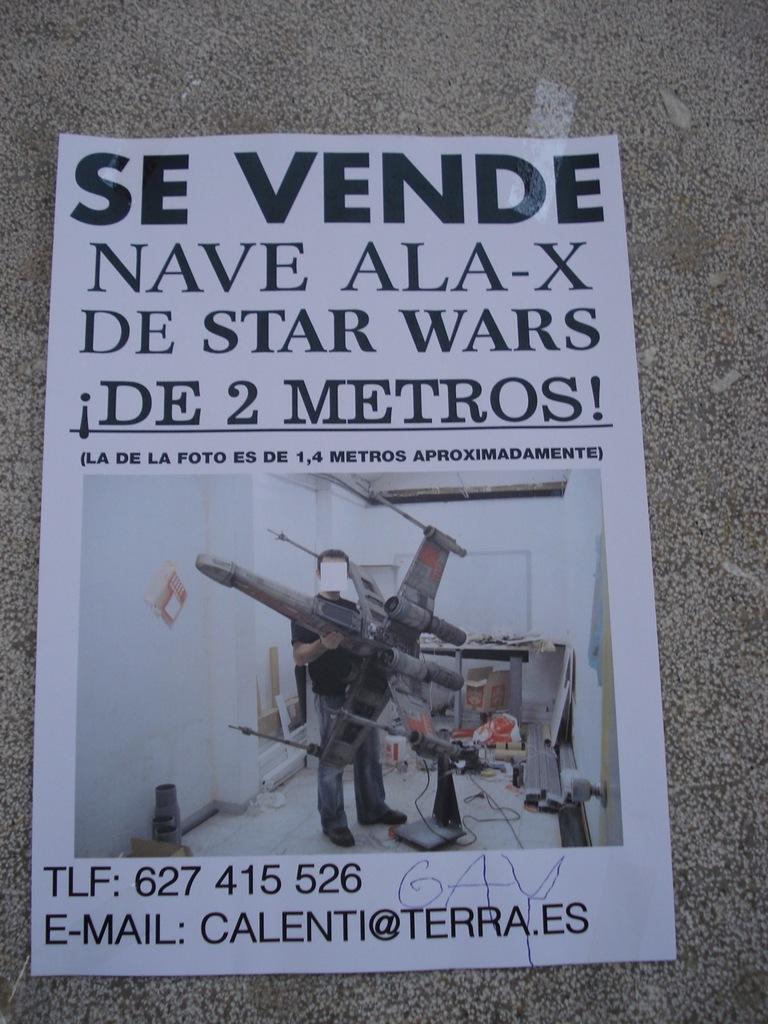What is the email listed?
Your response must be concise. Calenti@terra.es. What is the email address?
Provide a succinct answer. Calenti@terra.es. 